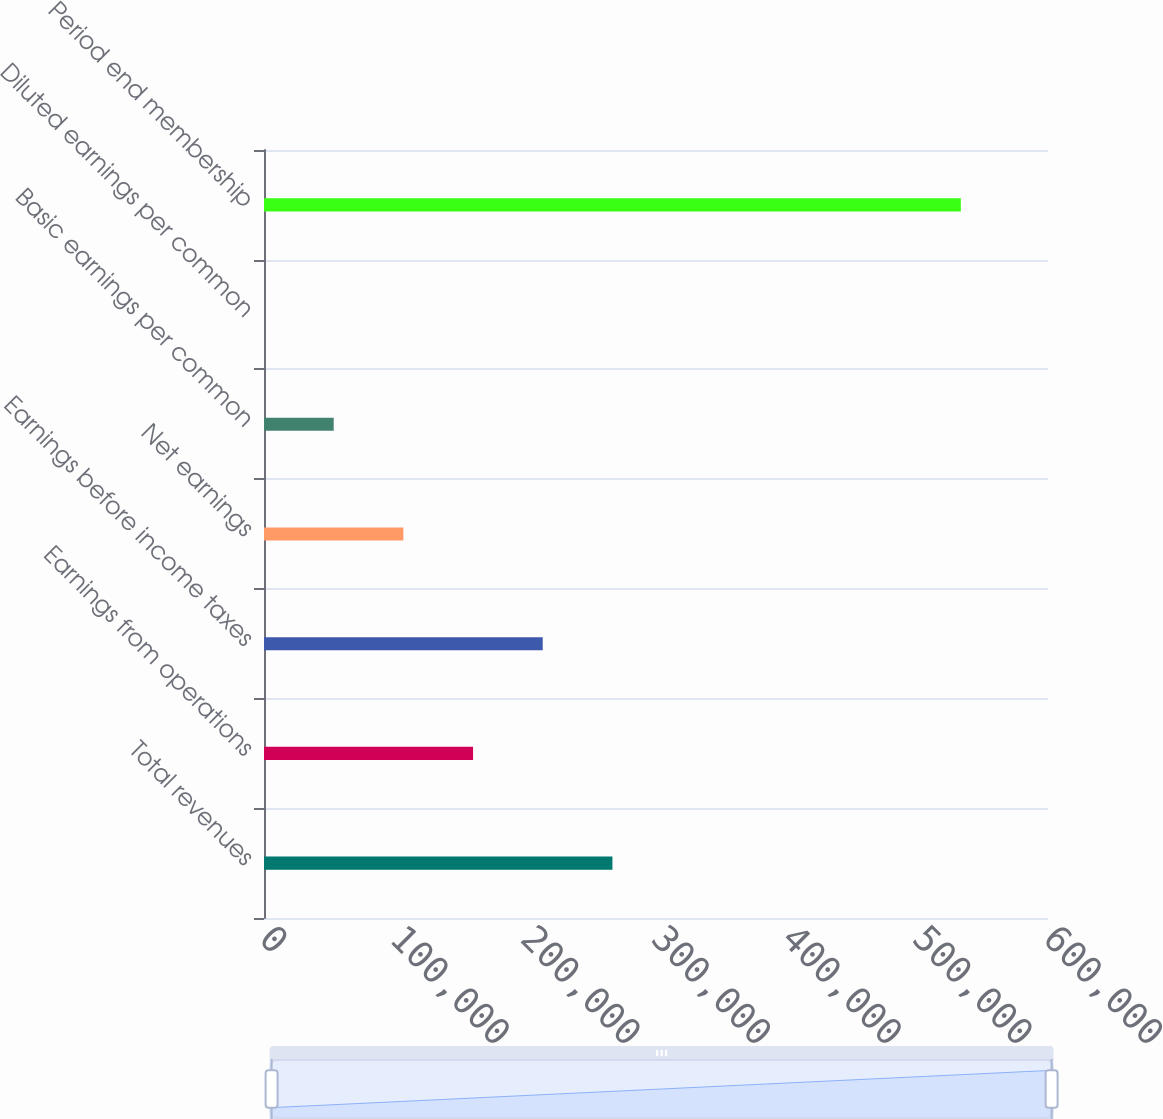Convert chart. <chart><loc_0><loc_0><loc_500><loc_500><bar_chart><fcel>Total revenues<fcel>Earnings from operations<fcel>Earnings before income taxes<fcel>Net earnings<fcel>Basic earnings per common<fcel>Diluted earnings per common<fcel>Period end membership<nl><fcel>266650<fcel>159990<fcel>213320<fcel>106660<fcel>53330.2<fcel>0.25<fcel>533300<nl></chart> 